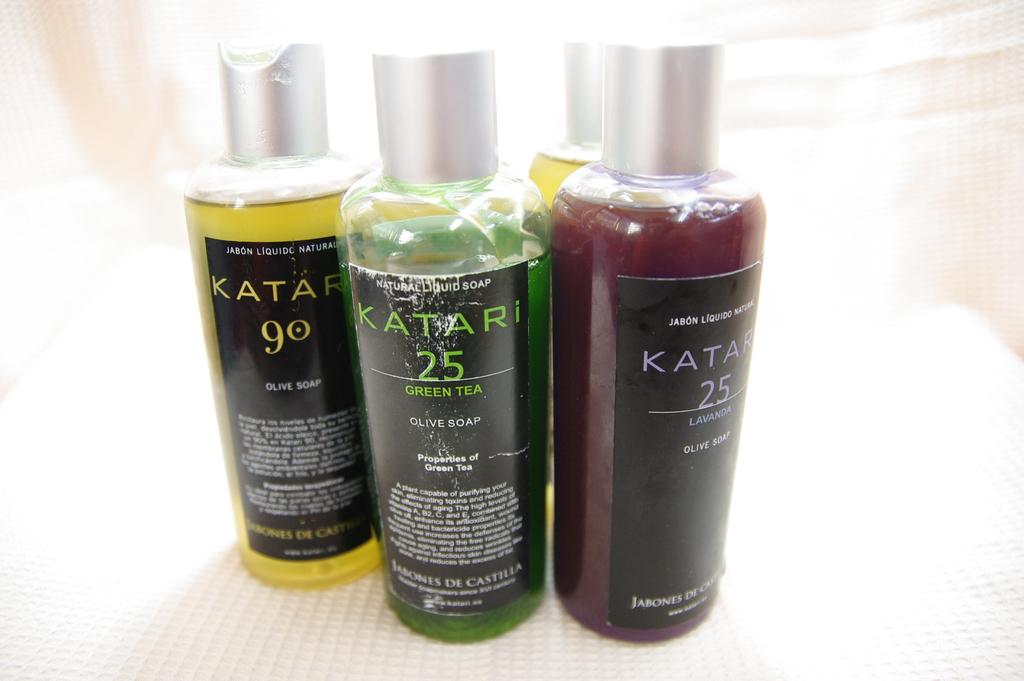Provide a one-sentence caption for the provided image. Three different coloured bottles from the brand Katari. 